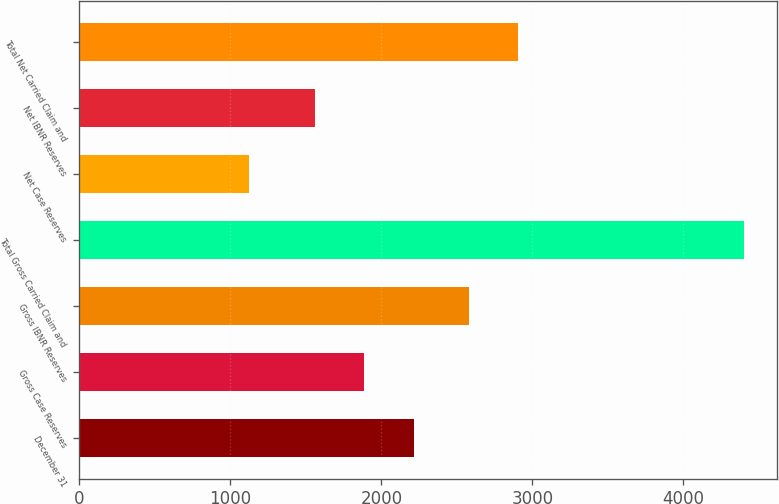Convert chart to OTSL. <chart><loc_0><loc_0><loc_500><loc_500><bar_chart><fcel>December 31<fcel>Gross Case Reserves<fcel>Gross IBNR Reserves<fcel>Total Gross Carried Claim and<fcel>Net Case Reserves<fcel>Net IBNR Reserves<fcel>Total Net Carried Claim and<nl><fcel>2216<fcel>1888.5<fcel>2578<fcel>4401<fcel>1126<fcel>1561<fcel>2905.5<nl></chart> 